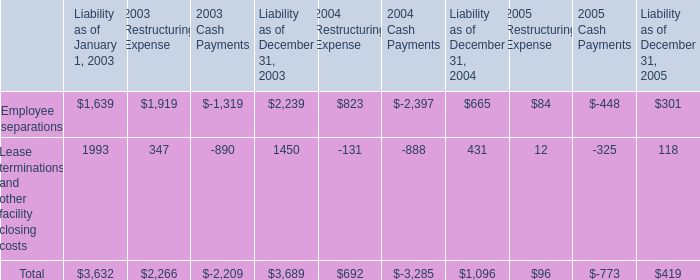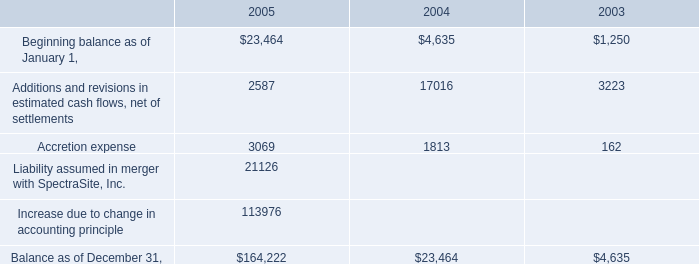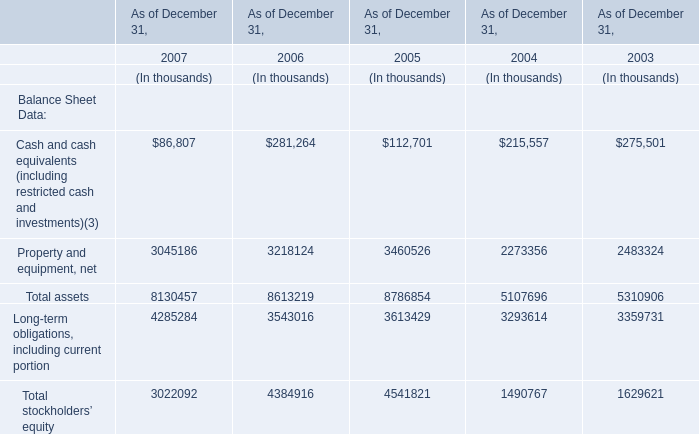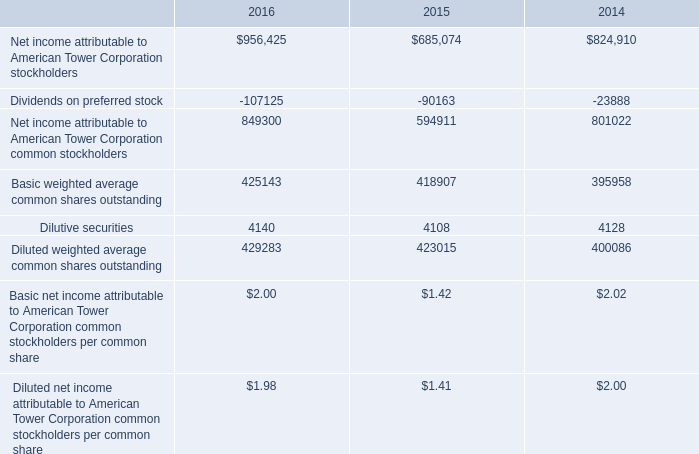What is the growing rate of Property and equipment, net in table 2 in the year with the most Total assets in table 2? (in %) 
Computations: ((3460526 - 2273356) / 2273356)
Answer: 0.52221. 